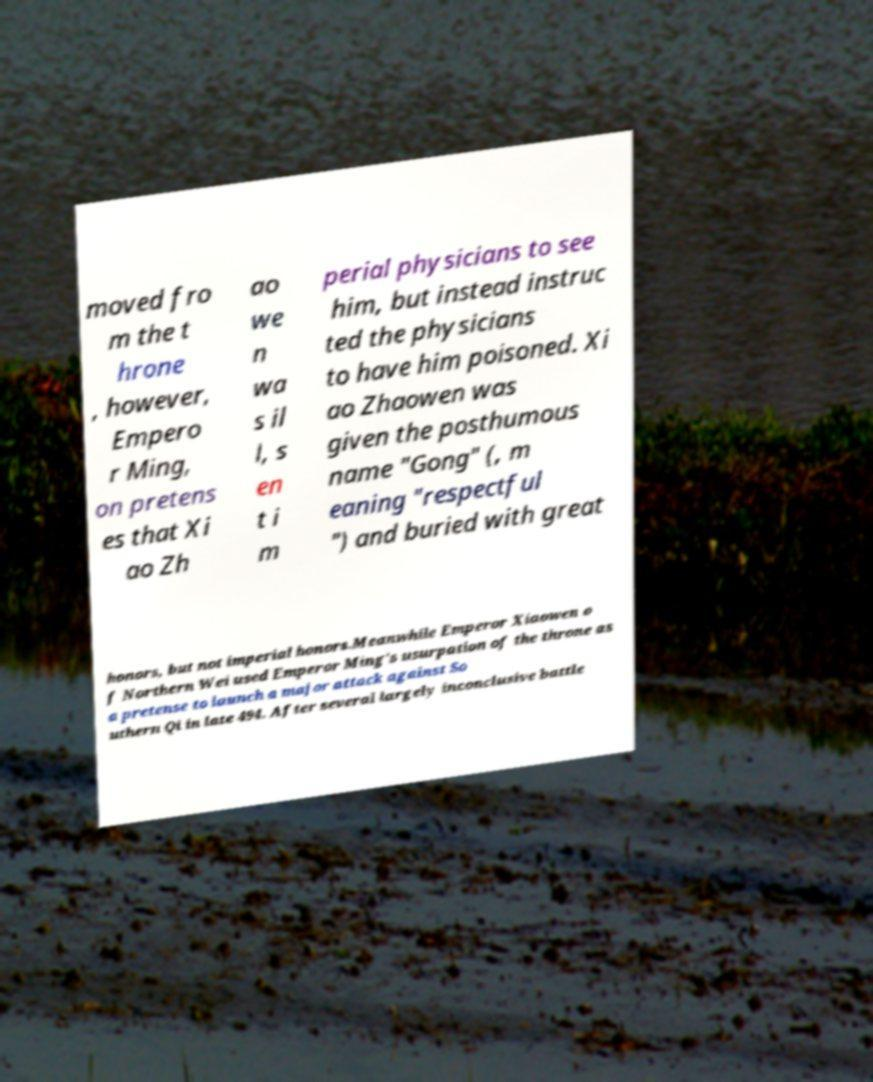Can you accurately transcribe the text from the provided image for me? moved fro m the t hrone , however, Empero r Ming, on pretens es that Xi ao Zh ao we n wa s il l, s en t i m perial physicians to see him, but instead instruc ted the physicians to have him poisoned. Xi ao Zhaowen was given the posthumous name "Gong" (, m eaning "respectful ") and buried with great honors, but not imperial honors.Meanwhile Emperor Xiaowen o f Northern Wei used Emperor Ming's usurpation of the throne as a pretense to launch a major attack against So uthern Qi in late 494. After several largely inconclusive battle 